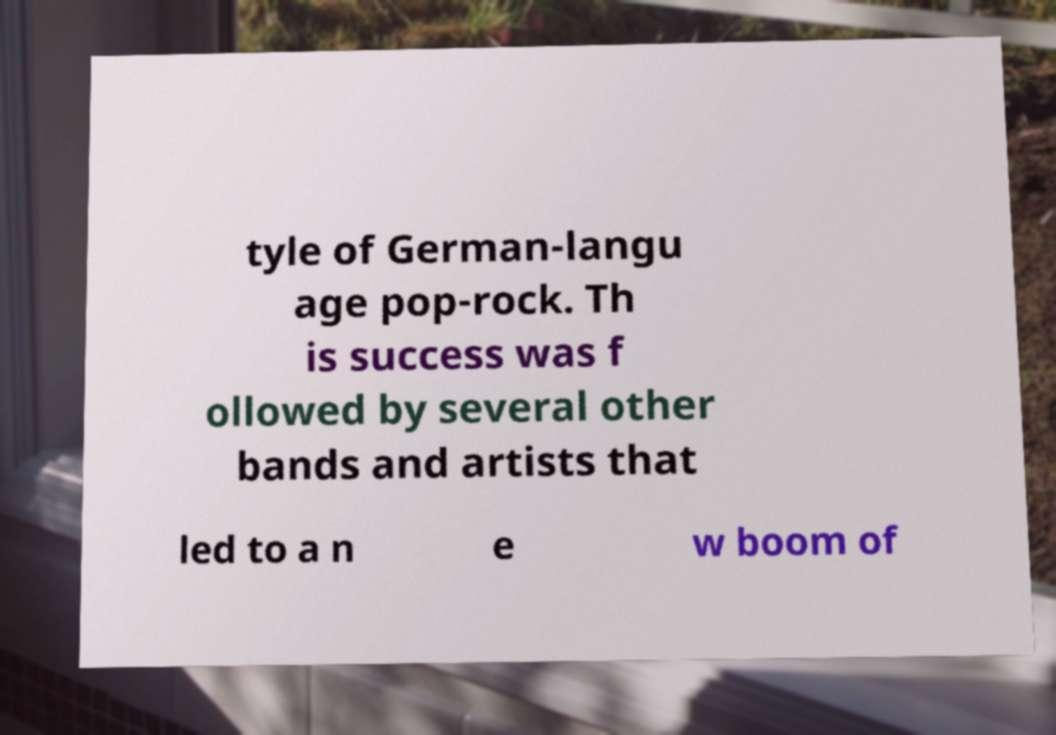What messages or text are displayed in this image? I need them in a readable, typed format. tyle of German-langu age pop-rock. Th is success was f ollowed by several other bands and artists that led to a n e w boom of 